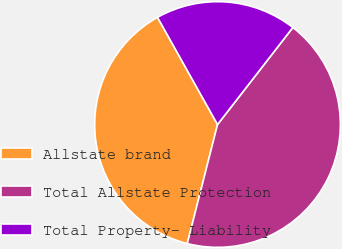<chart> <loc_0><loc_0><loc_500><loc_500><pie_chart><fcel>Allstate brand<fcel>Total Allstate Protection<fcel>Total Property- Liability<nl><fcel>37.92%<fcel>43.46%<fcel>18.63%<nl></chart> 